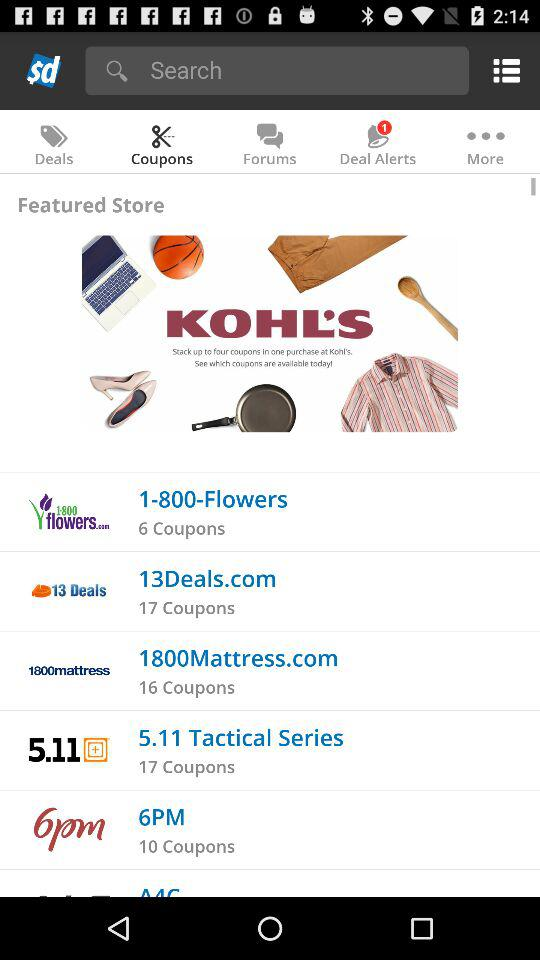What is the number of coupons in 6PM? The number of coupons in 6PM is 10. 